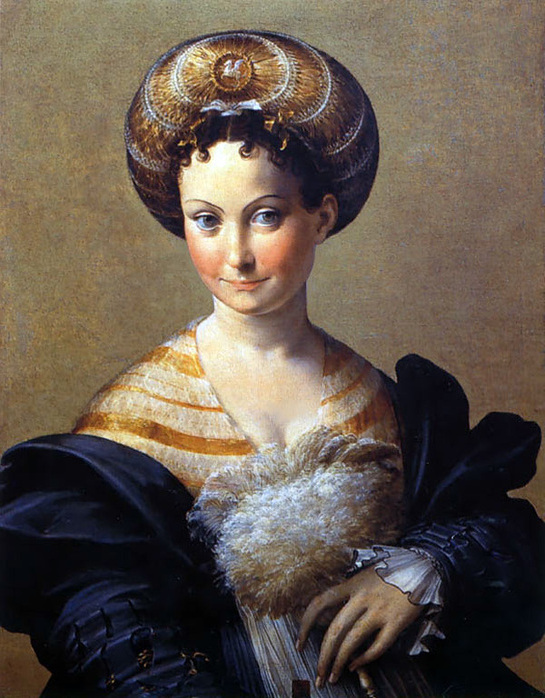How does the artist use color to emphasize the subject in this artwork? The artist employs a subtle yet effective use of color to draw focus to the subject. The soft, neutral beige of the background contrasts with the richer, more vivid tones of the subject's attire. This use of a muted palette for the background ensures that the viewer's attention is immediately drawn to the woman, her striking striped gown, and the intricate details of her headdress and shawl. 